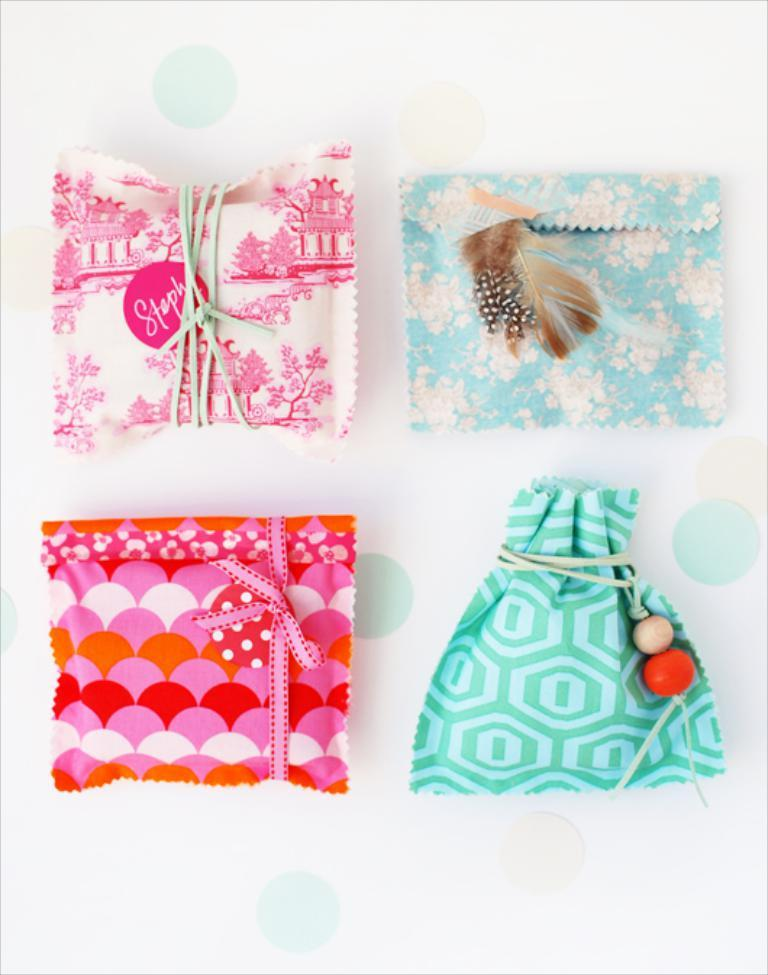What materials are the objects in the image made of? The objects in the image are made of different colors of cloth. How does the bucket contribute to the color scheme of the image? There is no bucket present in the image, so it cannot contribute to the color scheme. 